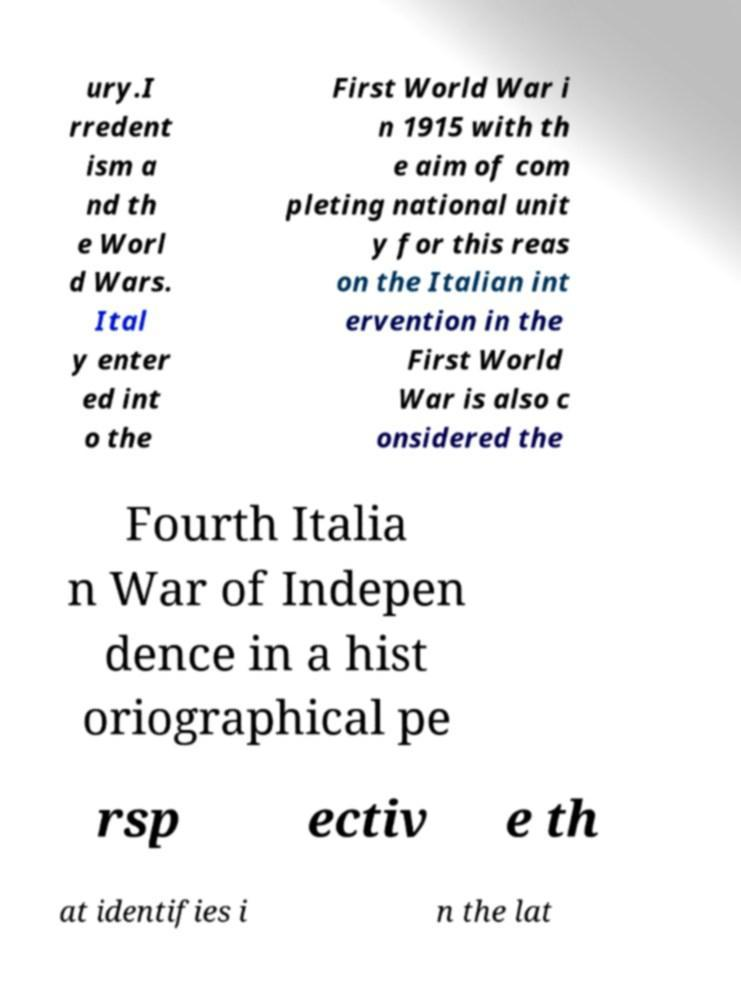Please read and relay the text visible in this image. What does it say? ury.I rredent ism a nd th e Worl d Wars. Ital y enter ed int o the First World War i n 1915 with th e aim of com pleting national unit y for this reas on the Italian int ervention in the First World War is also c onsidered the Fourth Italia n War of Indepen dence in a hist oriographical pe rsp ectiv e th at identifies i n the lat 